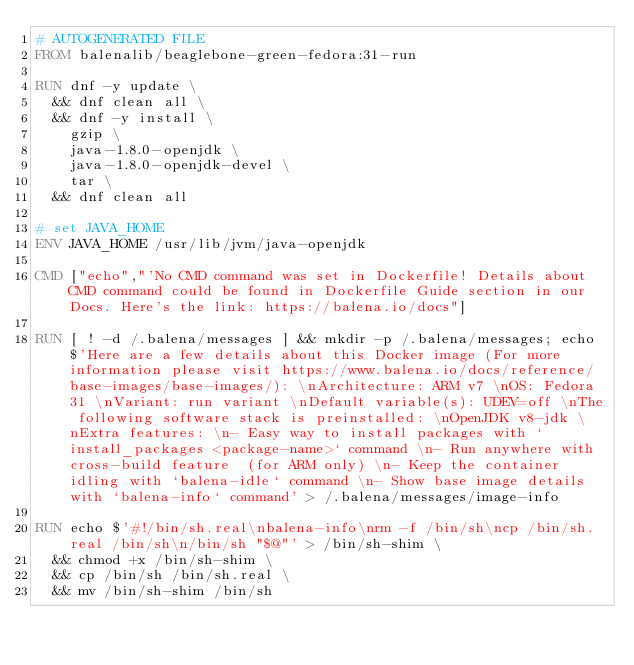<code> <loc_0><loc_0><loc_500><loc_500><_Dockerfile_># AUTOGENERATED FILE
FROM balenalib/beaglebone-green-fedora:31-run

RUN dnf -y update \
	&& dnf clean all \
	&& dnf -y install \
		gzip \
		java-1.8.0-openjdk \
		java-1.8.0-openjdk-devel \
		tar \
	&& dnf clean all

# set JAVA_HOME
ENV JAVA_HOME /usr/lib/jvm/java-openjdk

CMD ["echo","'No CMD command was set in Dockerfile! Details about CMD command could be found in Dockerfile Guide section in our Docs. Here's the link: https://balena.io/docs"]

RUN [ ! -d /.balena/messages ] && mkdir -p /.balena/messages; echo $'Here are a few details about this Docker image (For more information please visit https://www.balena.io/docs/reference/base-images/base-images/): \nArchitecture: ARM v7 \nOS: Fedora 31 \nVariant: run variant \nDefault variable(s): UDEV=off \nThe following software stack is preinstalled: \nOpenJDK v8-jdk \nExtra features: \n- Easy way to install packages with `install_packages <package-name>` command \n- Run anywhere with cross-build feature  (for ARM only) \n- Keep the container idling with `balena-idle` command \n- Show base image details with `balena-info` command' > /.balena/messages/image-info

RUN echo $'#!/bin/sh.real\nbalena-info\nrm -f /bin/sh\ncp /bin/sh.real /bin/sh\n/bin/sh "$@"' > /bin/sh-shim \
	&& chmod +x /bin/sh-shim \
	&& cp /bin/sh /bin/sh.real \
	&& mv /bin/sh-shim /bin/sh</code> 